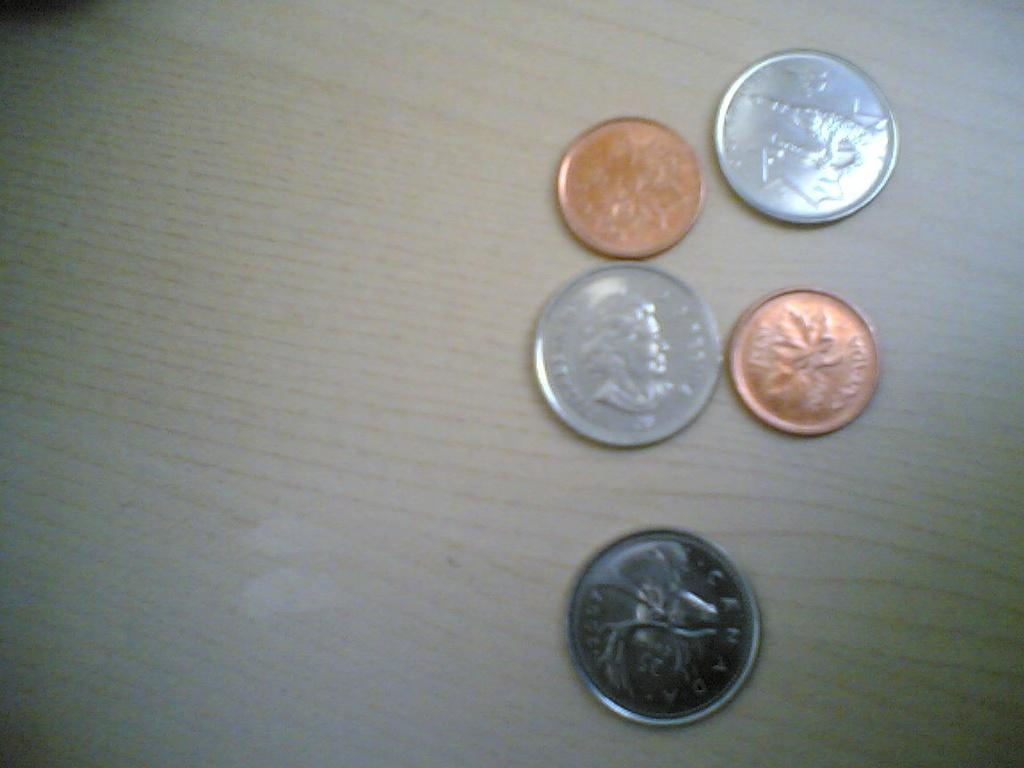<image>
Describe the image concisely. A penny with a maple leaf and the word CANADA sits with some other coins on a table. 